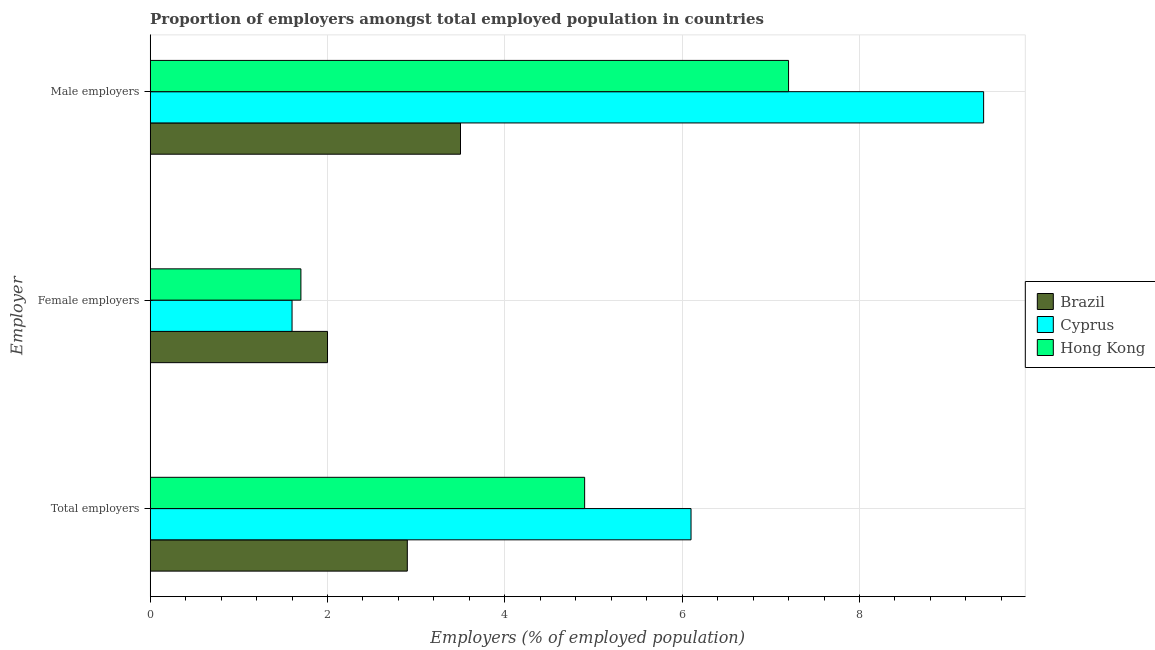How many different coloured bars are there?
Your response must be concise. 3. How many groups of bars are there?
Your answer should be compact. 3. How many bars are there on the 3rd tick from the top?
Give a very brief answer. 3. What is the label of the 3rd group of bars from the top?
Ensure brevity in your answer.  Total employers. What is the percentage of total employers in Cyprus?
Ensure brevity in your answer.  6.1. Across all countries, what is the maximum percentage of male employers?
Provide a short and direct response. 9.4. Across all countries, what is the minimum percentage of female employers?
Provide a succinct answer. 1.6. In which country was the percentage of total employers maximum?
Your answer should be compact. Cyprus. In which country was the percentage of male employers minimum?
Ensure brevity in your answer.  Brazil. What is the total percentage of total employers in the graph?
Your answer should be compact. 13.9. What is the difference between the percentage of female employers in Cyprus and that in Hong Kong?
Make the answer very short. -0.1. What is the difference between the percentage of female employers in Hong Kong and the percentage of male employers in Cyprus?
Offer a very short reply. -7.7. What is the average percentage of female employers per country?
Make the answer very short. 1.77. What is the difference between the percentage of male employers and percentage of total employers in Hong Kong?
Ensure brevity in your answer.  2.3. What is the ratio of the percentage of male employers in Hong Kong to that in Cyprus?
Give a very brief answer. 0.77. Is the percentage of total employers in Cyprus less than that in Hong Kong?
Offer a very short reply. No. Is the difference between the percentage of total employers in Hong Kong and Cyprus greater than the difference between the percentage of female employers in Hong Kong and Cyprus?
Your response must be concise. No. What is the difference between the highest and the second highest percentage of total employers?
Ensure brevity in your answer.  1.2. What is the difference between the highest and the lowest percentage of total employers?
Provide a succinct answer. 3.2. In how many countries, is the percentage of total employers greater than the average percentage of total employers taken over all countries?
Your answer should be compact. 2. What does the 2nd bar from the top in Total employers represents?
Your answer should be very brief. Cyprus. Is it the case that in every country, the sum of the percentage of total employers and percentage of female employers is greater than the percentage of male employers?
Provide a short and direct response. No. What is the difference between two consecutive major ticks on the X-axis?
Provide a succinct answer. 2. Does the graph contain grids?
Offer a very short reply. Yes. How are the legend labels stacked?
Make the answer very short. Vertical. What is the title of the graph?
Provide a succinct answer. Proportion of employers amongst total employed population in countries. What is the label or title of the X-axis?
Offer a terse response. Employers (% of employed population). What is the label or title of the Y-axis?
Keep it short and to the point. Employer. What is the Employers (% of employed population) in Brazil in Total employers?
Give a very brief answer. 2.9. What is the Employers (% of employed population) in Cyprus in Total employers?
Provide a short and direct response. 6.1. What is the Employers (% of employed population) of Hong Kong in Total employers?
Offer a very short reply. 4.9. What is the Employers (% of employed population) in Cyprus in Female employers?
Provide a short and direct response. 1.6. What is the Employers (% of employed population) of Hong Kong in Female employers?
Your response must be concise. 1.7. What is the Employers (% of employed population) of Brazil in Male employers?
Your answer should be compact. 3.5. What is the Employers (% of employed population) in Cyprus in Male employers?
Your answer should be very brief. 9.4. What is the Employers (% of employed population) in Hong Kong in Male employers?
Offer a terse response. 7.2. Across all Employer, what is the maximum Employers (% of employed population) of Cyprus?
Provide a short and direct response. 9.4. Across all Employer, what is the maximum Employers (% of employed population) of Hong Kong?
Keep it short and to the point. 7.2. Across all Employer, what is the minimum Employers (% of employed population) in Cyprus?
Keep it short and to the point. 1.6. Across all Employer, what is the minimum Employers (% of employed population) of Hong Kong?
Offer a terse response. 1.7. What is the total Employers (% of employed population) in Cyprus in the graph?
Your answer should be very brief. 17.1. What is the total Employers (% of employed population) of Hong Kong in the graph?
Ensure brevity in your answer.  13.8. What is the difference between the Employers (% of employed population) of Brazil in Total employers and that in Female employers?
Give a very brief answer. 0.9. What is the difference between the Employers (% of employed population) in Hong Kong in Total employers and that in Female employers?
Keep it short and to the point. 3.2. What is the difference between the Employers (% of employed population) of Hong Kong in Total employers and that in Male employers?
Offer a very short reply. -2.3. What is the difference between the Employers (% of employed population) in Brazil in Female employers and that in Male employers?
Offer a terse response. -1.5. What is the difference between the Employers (% of employed population) in Hong Kong in Female employers and that in Male employers?
Provide a succinct answer. -5.5. What is the difference between the Employers (% of employed population) of Brazil in Total employers and the Employers (% of employed population) of Hong Kong in Female employers?
Your response must be concise. 1.2. What is the difference between the Employers (% of employed population) of Brazil in Total employers and the Employers (% of employed population) of Cyprus in Male employers?
Your answer should be compact. -6.5. What is the difference between the Employers (% of employed population) in Brazil in Total employers and the Employers (% of employed population) in Hong Kong in Male employers?
Keep it short and to the point. -4.3. What is the difference between the Employers (% of employed population) in Cyprus in Total employers and the Employers (% of employed population) in Hong Kong in Male employers?
Ensure brevity in your answer.  -1.1. What is the difference between the Employers (% of employed population) of Brazil in Female employers and the Employers (% of employed population) of Cyprus in Male employers?
Your answer should be compact. -7.4. What is the difference between the Employers (% of employed population) of Cyprus in Female employers and the Employers (% of employed population) of Hong Kong in Male employers?
Make the answer very short. -5.6. What is the average Employers (% of employed population) of Cyprus per Employer?
Ensure brevity in your answer.  5.7. What is the average Employers (% of employed population) of Hong Kong per Employer?
Provide a short and direct response. 4.6. What is the difference between the Employers (% of employed population) of Brazil and Employers (% of employed population) of Hong Kong in Total employers?
Keep it short and to the point. -2. What is the difference between the Employers (% of employed population) of Brazil and Employers (% of employed population) of Hong Kong in Female employers?
Provide a succinct answer. 0.3. What is the difference between the Employers (% of employed population) of Cyprus and Employers (% of employed population) of Hong Kong in Female employers?
Make the answer very short. -0.1. What is the difference between the Employers (% of employed population) in Brazil and Employers (% of employed population) in Cyprus in Male employers?
Provide a succinct answer. -5.9. What is the ratio of the Employers (% of employed population) of Brazil in Total employers to that in Female employers?
Provide a short and direct response. 1.45. What is the ratio of the Employers (% of employed population) in Cyprus in Total employers to that in Female employers?
Ensure brevity in your answer.  3.81. What is the ratio of the Employers (% of employed population) in Hong Kong in Total employers to that in Female employers?
Your response must be concise. 2.88. What is the ratio of the Employers (% of employed population) in Brazil in Total employers to that in Male employers?
Your response must be concise. 0.83. What is the ratio of the Employers (% of employed population) of Cyprus in Total employers to that in Male employers?
Your answer should be very brief. 0.65. What is the ratio of the Employers (% of employed population) of Hong Kong in Total employers to that in Male employers?
Ensure brevity in your answer.  0.68. What is the ratio of the Employers (% of employed population) of Brazil in Female employers to that in Male employers?
Make the answer very short. 0.57. What is the ratio of the Employers (% of employed population) of Cyprus in Female employers to that in Male employers?
Your answer should be compact. 0.17. What is the ratio of the Employers (% of employed population) of Hong Kong in Female employers to that in Male employers?
Give a very brief answer. 0.24. What is the difference between the highest and the second highest Employers (% of employed population) of Cyprus?
Keep it short and to the point. 3.3. What is the difference between the highest and the lowest Employers (% of employed population) of Brazil?
Offer a terse response. 1.5. What is the difference between the highest and the lowest Employers (% of employed population) of Cyprus?
Ensure brevity in your answer.  7.8. 